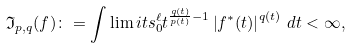Convert formula to latex. <formula><loc_0><loc_0><loc_500><loc_500>\mathcal { \mathfrak { I } } _ { p , q } ( f ) \colon = \int \lim i t s _ { 0 } ^ { \ell } t ^ { \frac { q ( t ) } { p ( t ) } - 1 } \left | f ^ { \ast } ( t ) \right | ^ { q ( t ) } \, d t < \infty ,</formula> 